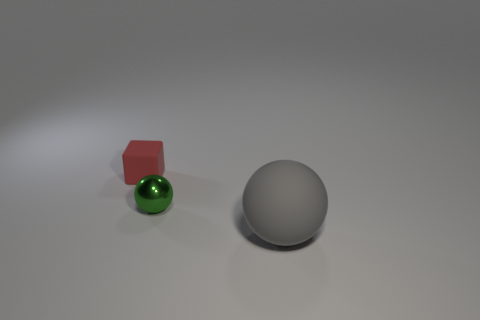What number of other objects are there of the same material as the gray object?
Offer a very short reply. 1. Are there any other things that have the same shape as the shiny object?
Provide a succinct answer. Yes. There is a sphere that is to the left of the rubber object in front of the red rubber thing; how big is it?
Your answer should be very brief. Small. Are there the same number of tiny red things right of the rubber block and tiny green things on the left side of the big matte sphere?
Ensure brevity in your answer.  No. Are there any other things that have the same size as the gray matte thing?
Make the answer very short. No. What is the color of the cube that is made of the same material as the large ball?
Your response must be concise. Red. Is the block made of the same material as the thing in front of the small green object?
Your response must be concise. Yes. What color is the object that is left of the large ball and in front of the small matte block?
Give a very brief answer. Green. What number of spheres are green objects or gray matte objects?
Keep it short and to the point. 2. There is a red object; does it have the same shape as the rubber object in front of the small metallic sphere?
Keep it short and to the point. No. 